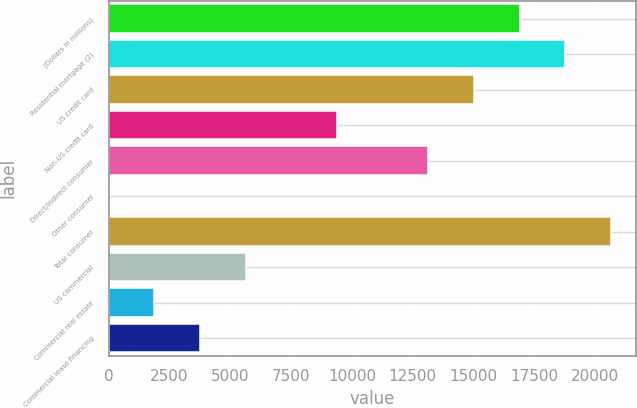<chart> <loc_0><loc_0><loc_500><loc_500><bar_chart><fcel>(Dollars in millions)<fcel>Residential mortgage (2)<fcel>US credit card<fcel>Non-US credit card<fcel>Direct/Indirect consumer<fcel>Other consumer<fcel>Total consumer<fcel>US commercial<fcel>Commercial real estate<fcel>Commercial lease financing<nl><fcel>16883.3<fcel>18759<fcel>15007.6<fcel>9380.5<fcel>13131.9<fcel>2<fcel>20634.7<fcel>5629.1<fcel>1877.7<fcel>3753.4<nl></chart> 